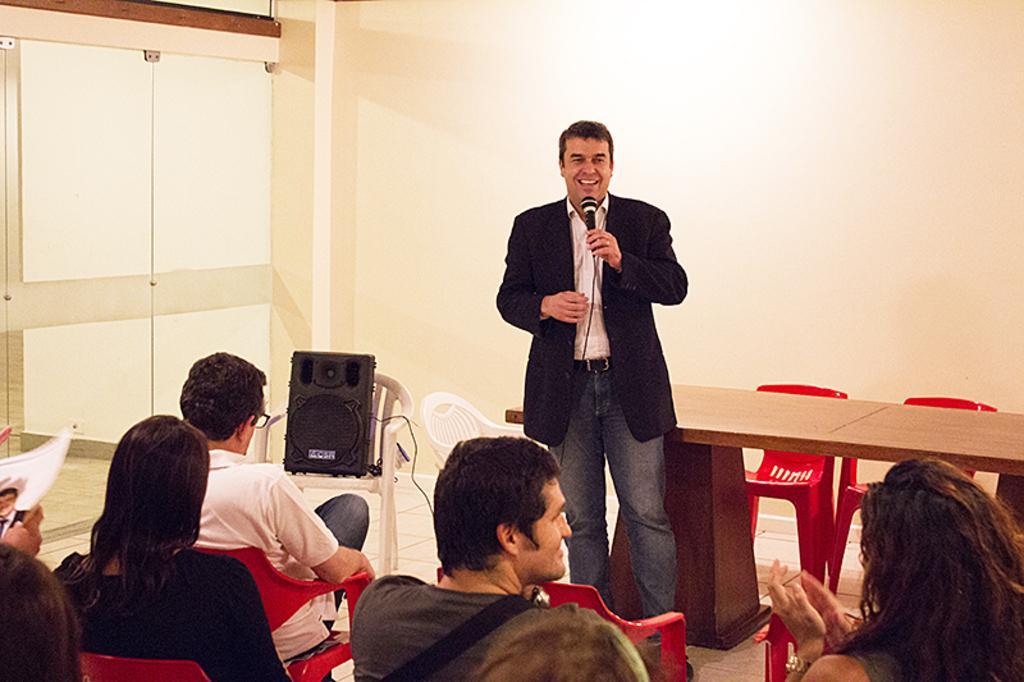Describe this image in one or two sentences. In this image, we can see a group of people. At the bottom, we can see few people are sitting on a chair. Here a person is standing and holding a microphone. He is smiling. Here we can see few chairs, speaker, wire, table. Background there is a wall, glass doors. On the left side, we can see some magazine. 